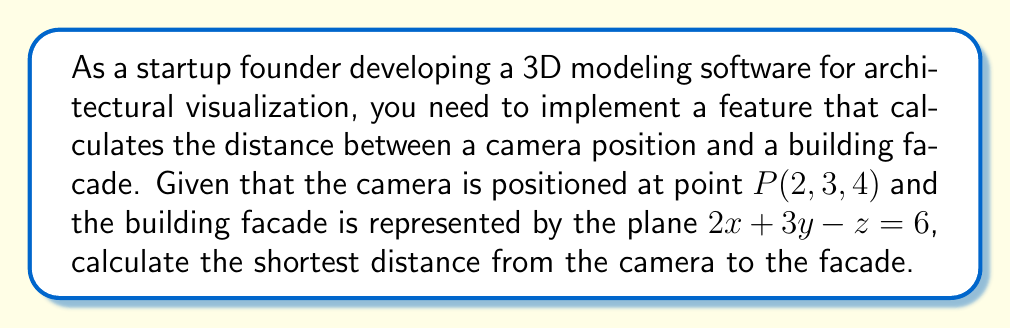Give your solution to this math problem. To solve this problem, we'll use the formula for the distance from a point to a plane in 3D space. The general formula is:

$$d = \frac{|Ax_0 + By_0 + Cz_0 + D|}{\sqrt{A^2 + B^2 + C^2}}$$

Where $(x_0, y_0, z_0)$ is the point, and $Ax + By + Cz + D = 0$ is the equation of the plane.

Step 1: Identify the components from the given information:
- Point $P(x_0, y_0, z_0) = (2, 3, 4)$
- Plane equation: $2x + 3y - z = 6$, which we need to rewrite as $2x + 3y - z - 6 = 0$

So, $A = 2$, $B = 3$, $C = -1$, and $D = -6$

Step 2: Substitute these values into the formula:

$$d = \frac{|2(2) + 3(3) + (-1)(4) + (-6)|}{\sqrt{2^2 + 3^2 + (-1)^2}}$$

Step 3: Simplify the numerator:
$$d = \frac{|4 + 9 - 4 - 6|}{\sqrt{4 + 9 + 1}}$$
$$d = \frac{|3|}{\sqrt{14}}$$

Step 4: Simplify the fraction:
$$d = \frac{3}{\sqrt{14}}$$

Step 5: To get a decimal approximation, divide 3 by $\sqrt{14}$:
$$d \approx 0.8018$$

Therefore, the shortest distance from the camera to the building facade is approximately 0.8018 units.
Answer: $\frac{3}{\sqrt{14}} \approx 0.8018$ units 